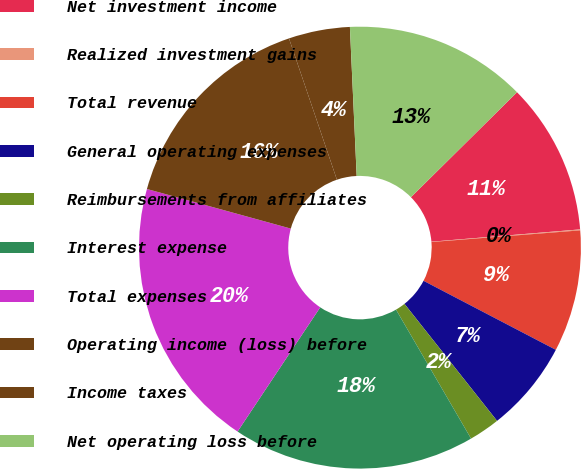<chart> <loc_0><loc_0><loc_500><loc_500><pie_chart><fcel>Net investment income<fcel>Realized investment gains<fcel>Total revenue<fcel>General operating expenses<fcel>Reimbursements from affiliates<fcel>Interest expense<fcel>Total expenses<fcel>Operating income (loss) before<fcel>Income taxes<fcel>Net operating loss before<nl><fcel>11.1%<fcel>0.07%<fcel>8.9%<fcel>6.69%<fcel>2.27%<fcel>17.73%<fcel>19.93%<fcel>15.52%<fcel>4.48%<fcel>13.31%<nl></chart> 